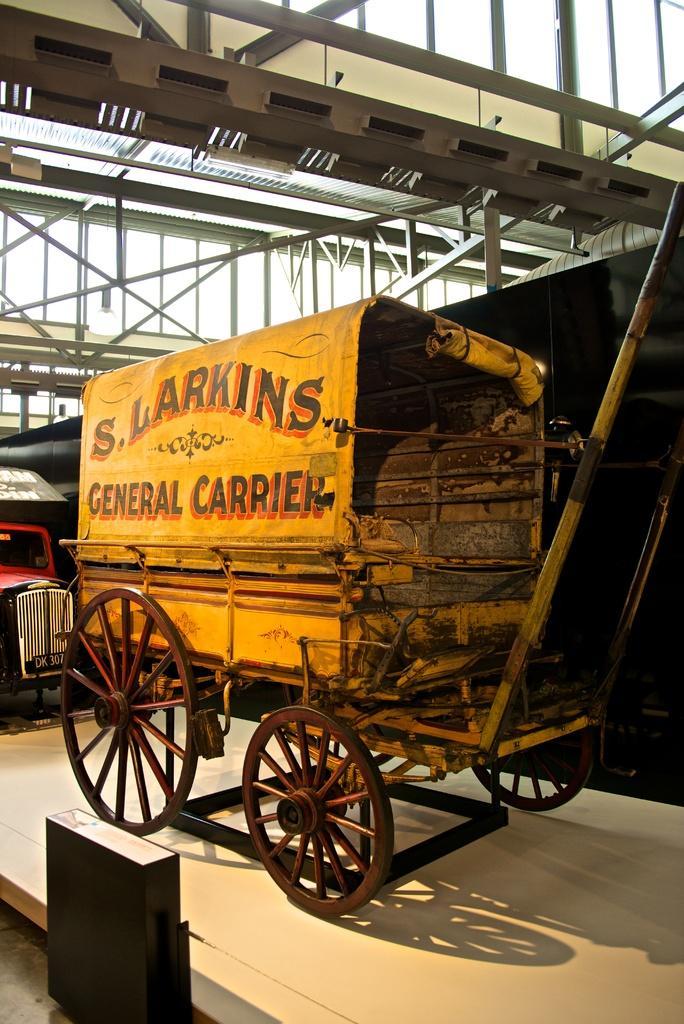Please provide a concise description of this image. In the center of the image we can see vehicle on the floor. In the background we can see poles, windows, lights and wall. 